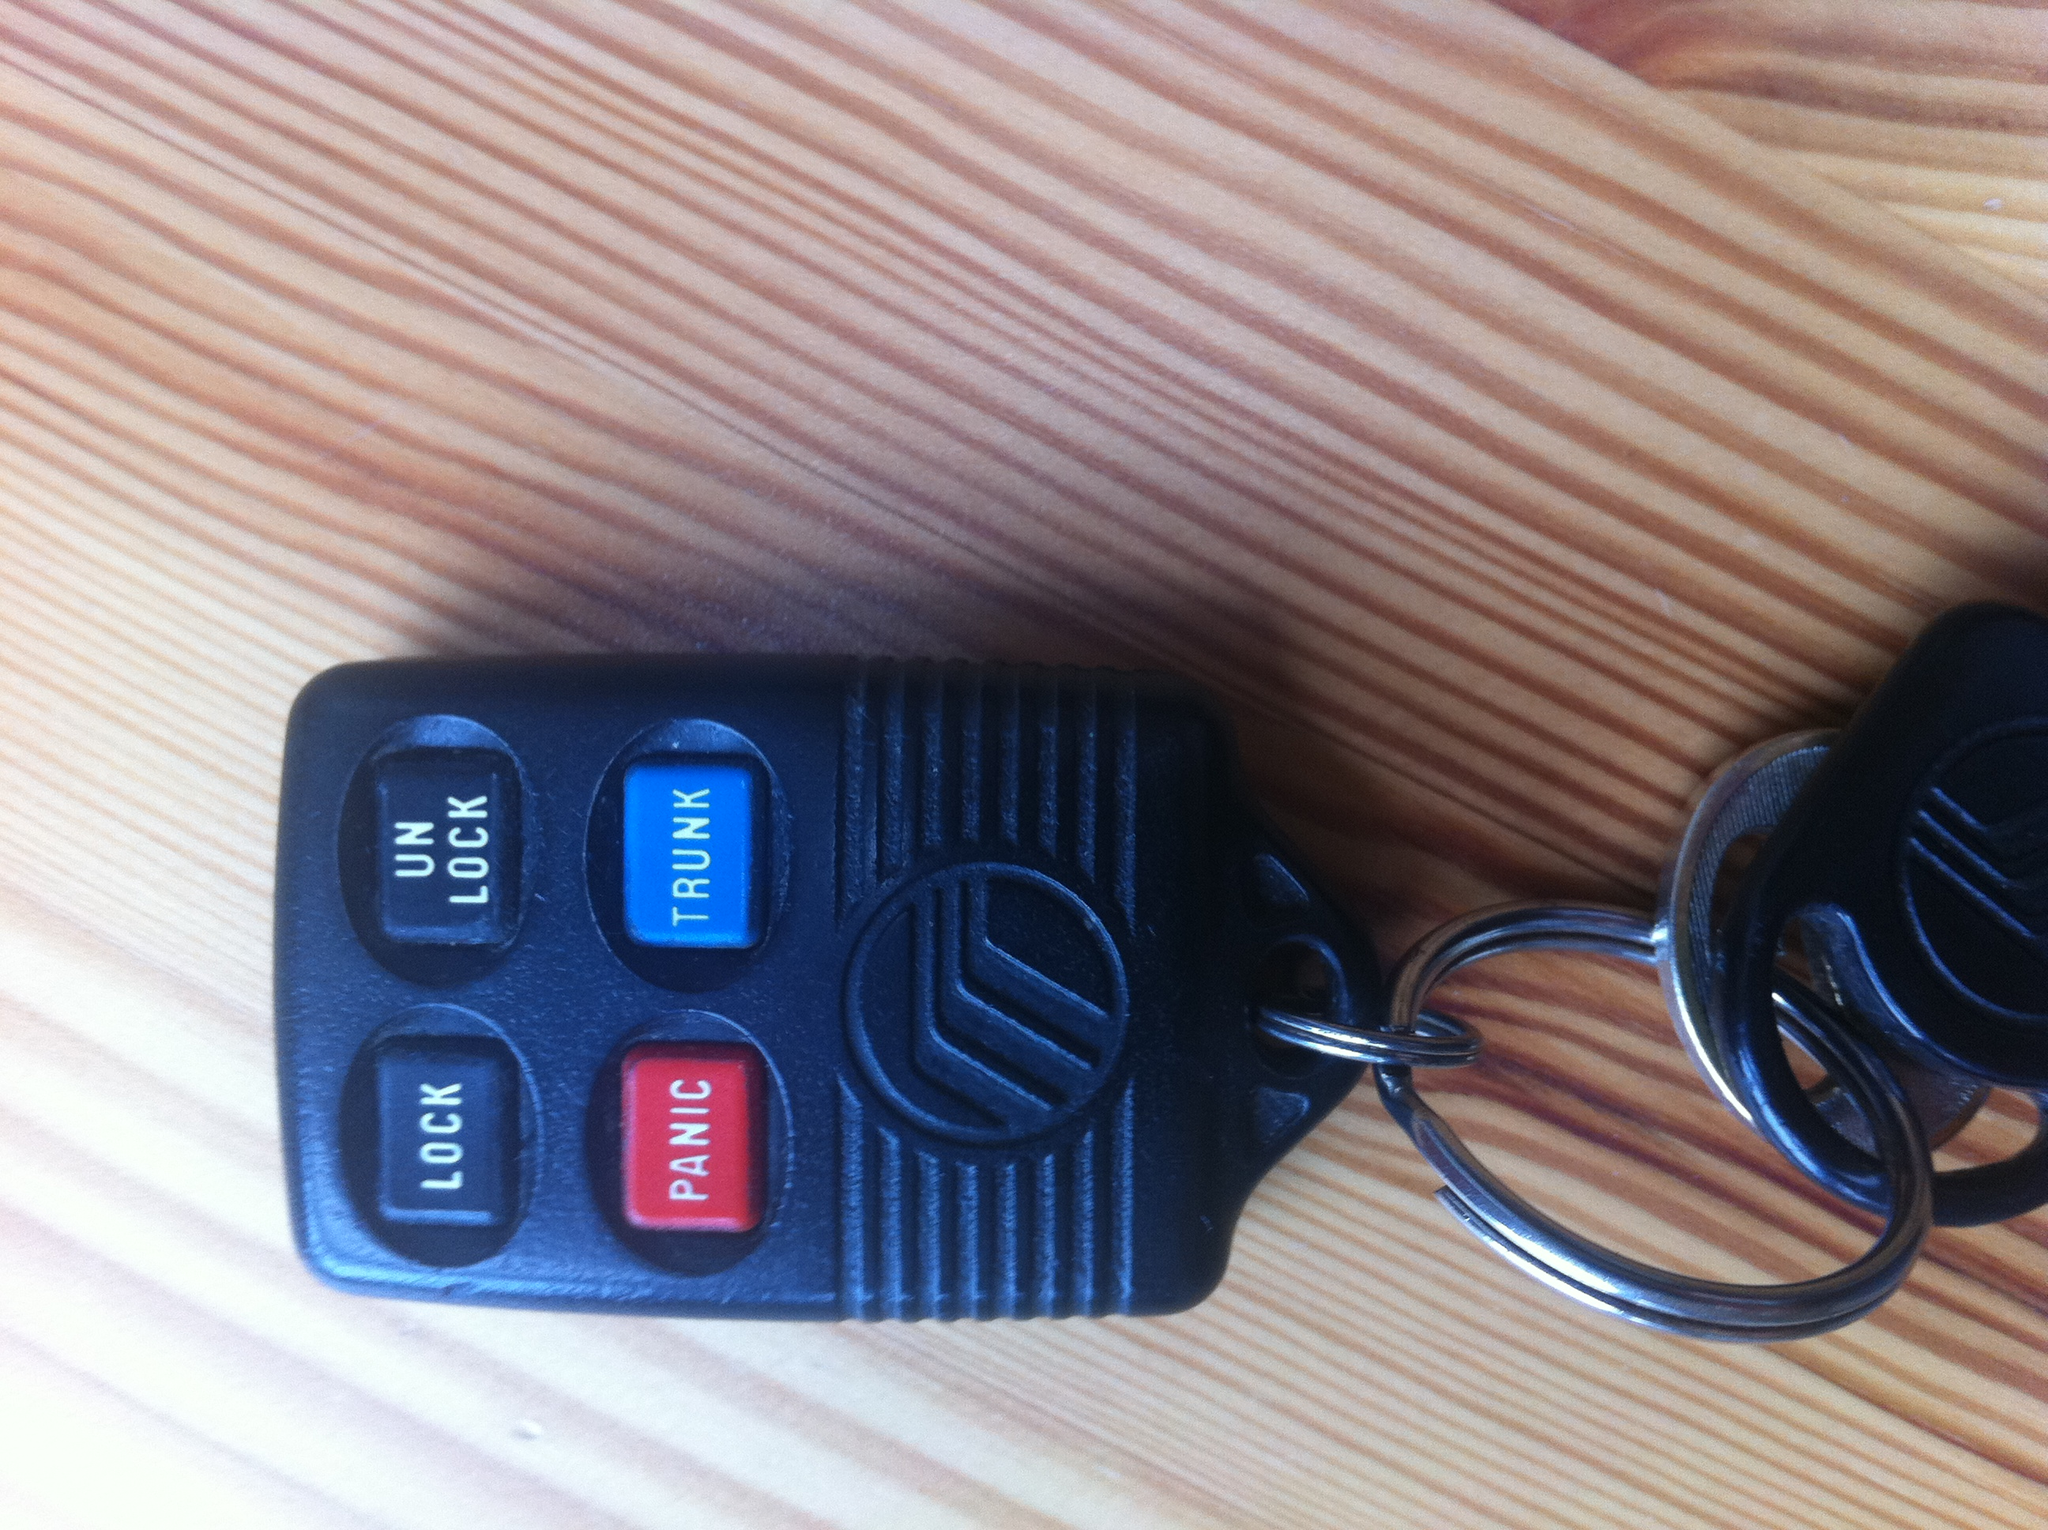Describe a short realistic scenario where the 'TRUNK' button might be essential. A short realistic scenario where the 'TRUNK' button might be essential is when a person is carrying groceries to their car. When their hands are full, they can simply press the 'TRUNK' button to open the trunk automatically, enabling them to load their groceries without needing to manually unlock and open the trunk. 